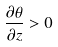Convert formula to latex. <formula><loc_0><loc_0><loc_500><loc_500>\frac { \partial \theta } { \partial z } > 0</formula> 